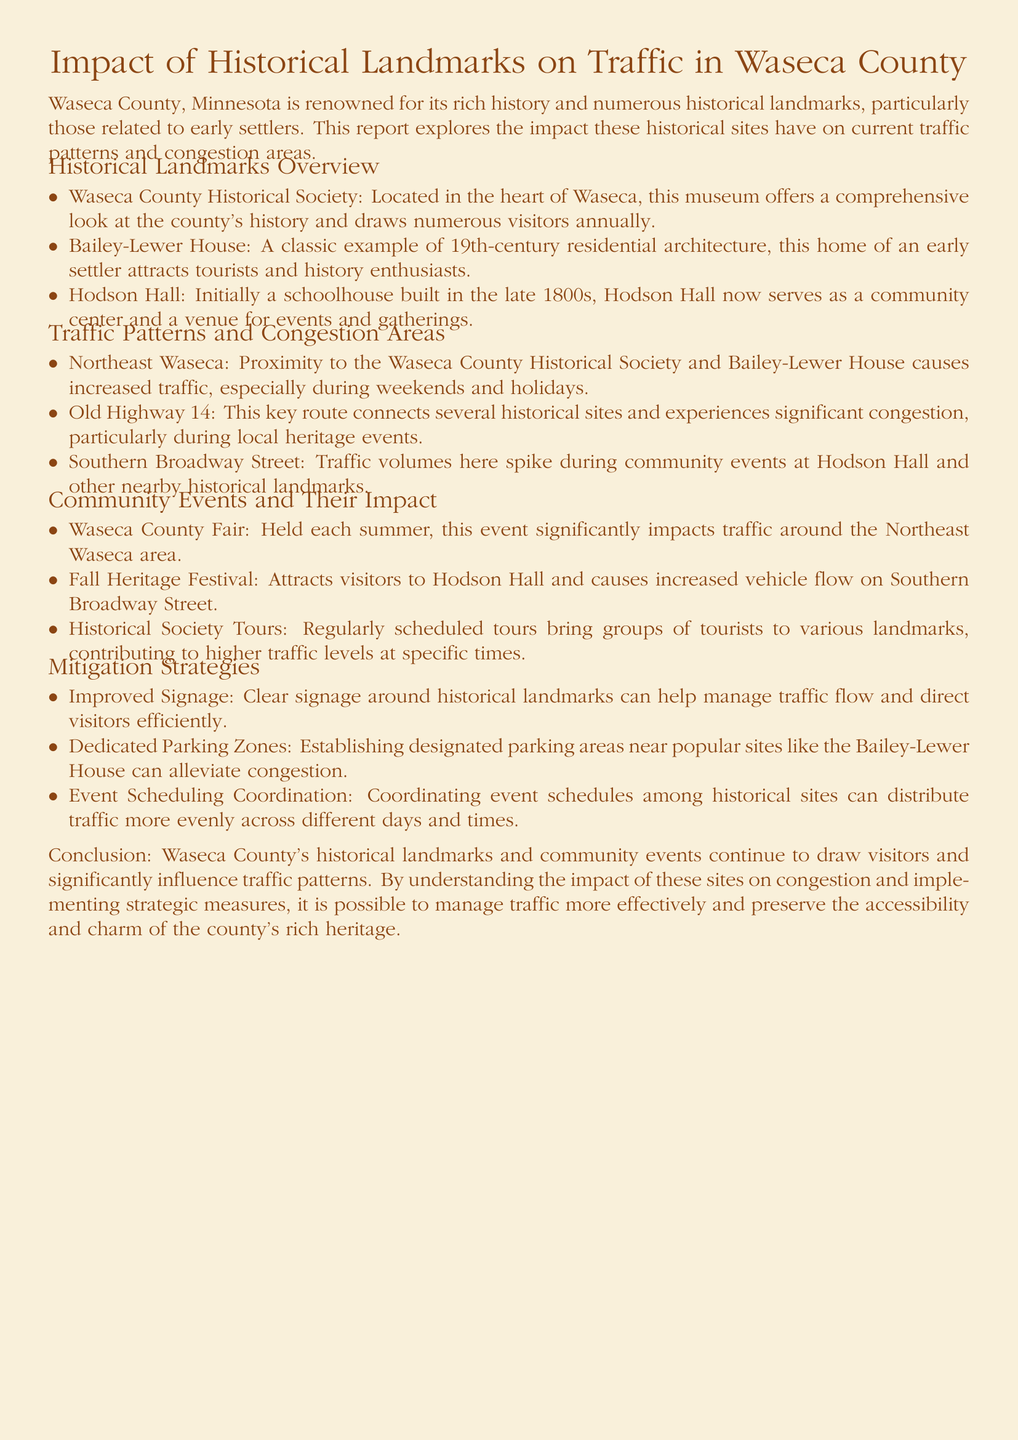What historical sites are located in Waseca County? The document lists several sites including the Waseca County Historical Society, Bailey-Lewer House, and Hodson Hall.
Answer: Waseca County Historical Society, Bailey-Lewer House, Hodson Hall Which street experiences significant congestion during local heritage events? The document indicates that Old Highway 14 is a key route that experiences significant congestion during such events.
Answer: Old Highway 14 What is a major event that affects traffic in Northeast Waseca? The Waseca County Fair is mentioned as a significant event impacting traffic in the Northeast Waseca area.
Answer: Waseca County Fair What strategy involves the establishment of designated parking areas? The document mentions that establishing dedicated parking zones is one of the mitigation strategies.
Answer: Dedicated Parking Zones What does Hodson Hall serve as today? The document states that Hodson Hall now serves as a community center and venue for events and gatherings.
Answer: Community center and venue for events How can traffic flow be managed around historical landmarks? Improved signage can help manage traffic flow and direct visitors efficiently, according to the document.
Answer: Improved Signage Which street sees traffic spikes during community events at Hodson Hall? The document specifies that Southern Broadway Street sees traffic spikes during community events at Hodson Hall.
Answer: Southern Broadway Street What type of document is this? The content and structure presented in the document indicates that it is a traffic report focusing on historical landmarks.
Answer: Traffic report 